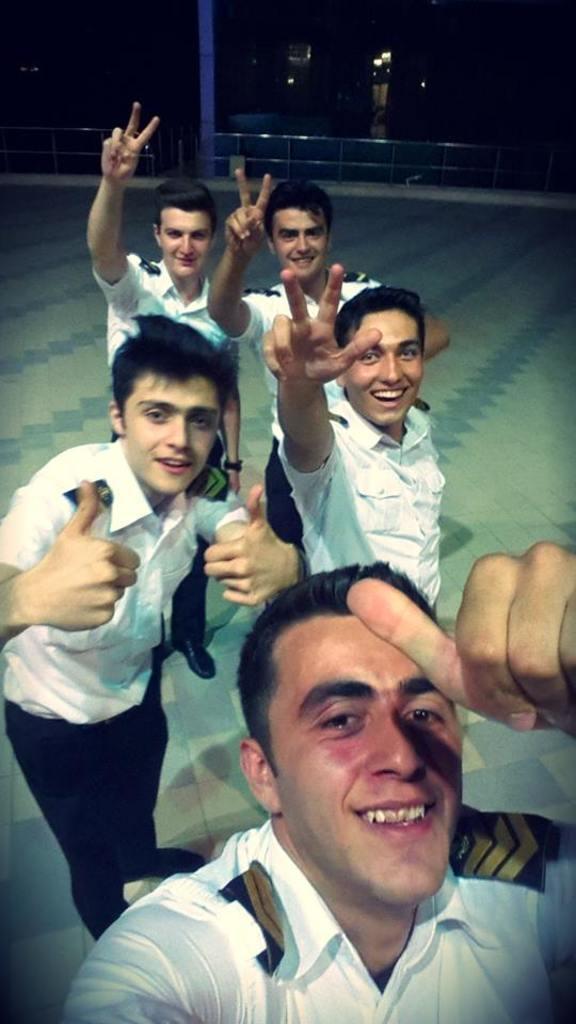In one or two sentences, can you explain what this image depicts? In the image i can see people are standing and smiling and in the background i can see lights and some other objects. 